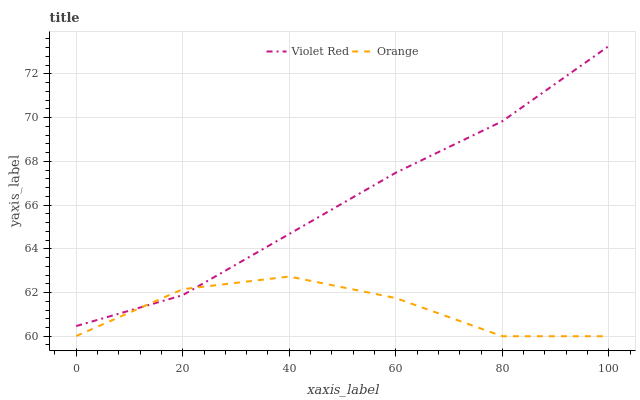Does Orange have the minimum area under the curve?
Answer yes or no. Yes. Does Violet Red have the maximum area under the curve?
Answer yes or no. Yes. Does Violet Red have the minimum area under the curve?
Answer yes or no. No. Is Violet Red the smoothest?
Answer yes or no. Yes. Is Orange the roughest?
Answer yes or no. Yes. Is Violet Red the roughest?
Answer yes or no. No. Does Orange have the lowest value?
Answer yes or no. Yes. Does Violet Red have the lowest value?
Answer yes or no. No. Does Violet Red have the highest value?
Answer yes or no. Yes. Does Orange intersect Violet Red?
Answer yes or no. Yes. Is Orange less than Violet Red?
Answer yes or no. No. Is Orange greater than Violet Red?
Answer yes or no. No. 